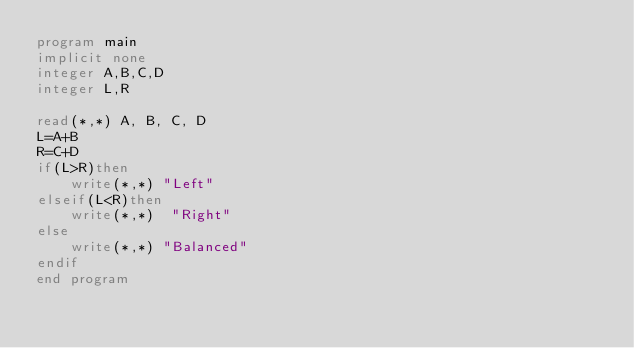<code> <loc_0><loc_0><loc_500><loc_500><_FORTRAN_>program main
implicit none
integer A,B,C,D
integer L,R
 
read(*,*) A, B, C, D
L=A+B
R=C+D
if(L>R)then
	write(*,*) "Left"
elseif(L<R)then
	write(*,*)	"Right"
else
	write(*,*) "Balanced"
endif
end program</code> 